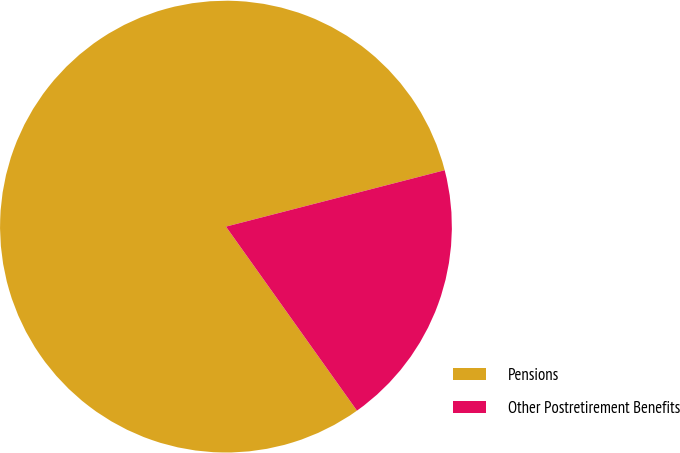Convert chart to OTSL. <chart><loc_0><loc_0><loc_500><loc_500><pie_chart><fcel>Pensions<fcel>Other Postretirement Benefits<nl><fcel>80.83%<fcel>19.17%<nl></chart> 